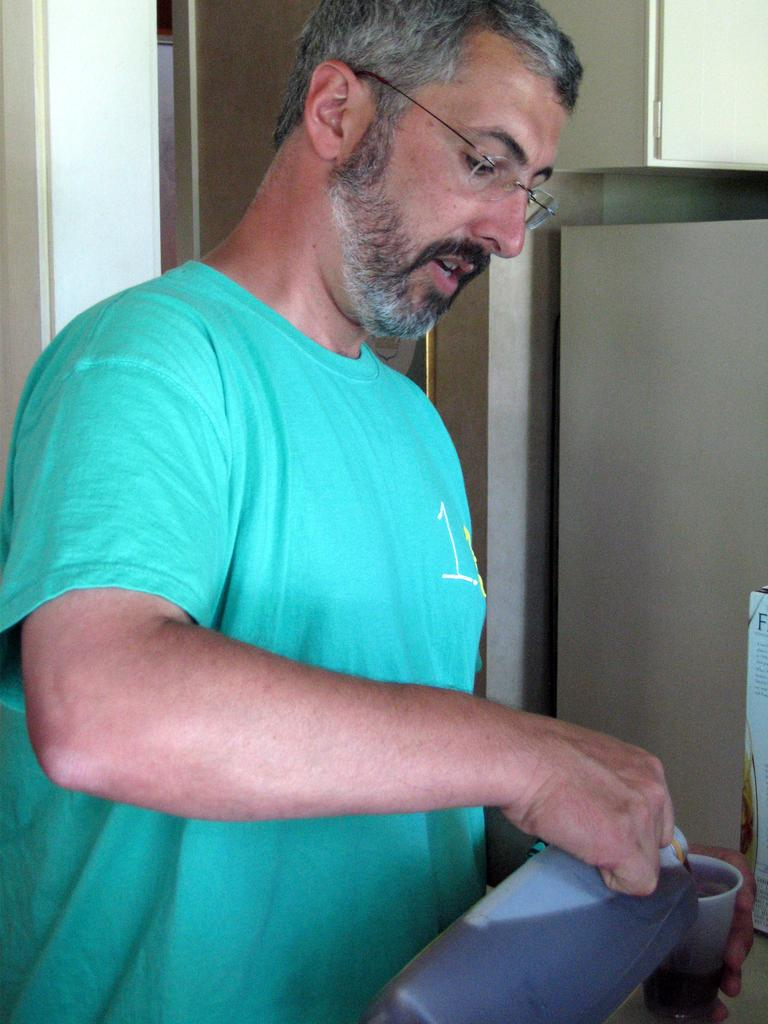What is the main subject of the image? There is a man in the image. What is the man wearing? The man is wearing a T-shirt. What objects is the man holding? The man is holding a bottle and a cup. What can be seen in the background of the image? There is a wall in the background of the image. Are there any architectural features visible in the background? Yes, there is a door in the wall in the background of the image. What type of chairs can be seen in the image? There are no chairs present in the image. What flavor of jam is the man spreading on his toast in the image? There is no toast or jam present in the image. 